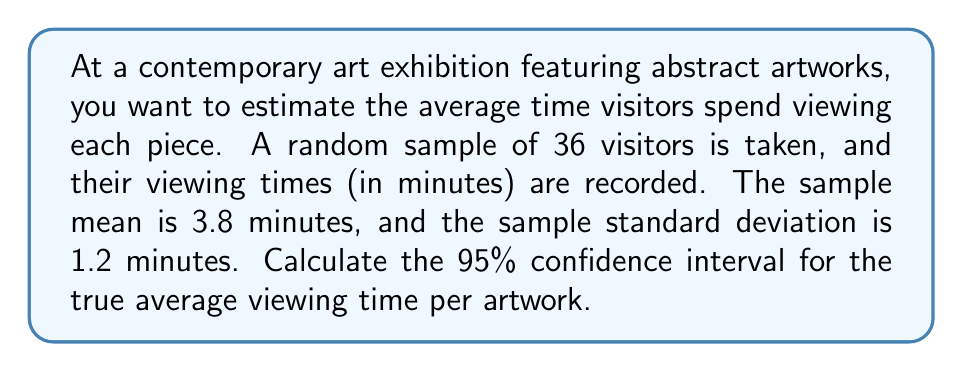Give your solution to this math problem. Let's approach this step-by-step:

1) We're dealing with a confidence interval for a population mean with unknown population standard deviation. We'll use the t-distribution.

2) Given information:
   - Sample size: $n = 36$
   - Sample mean: $\bar{x} = 3.8$ minutes
   - Sample standard deviation: $s = 1.2$ minutes
   - Confidence level: 95%

3) The formula for the confidence interval is:

   $$\bar{x} \pm t_{\alpha/2, n-1} \cdot \frac{s}{\sqrt{n}}$$

4) We need to find $t_{\alpha/2, n-1}$:
   - $\alpha = 1 - 0.95 = 0.05$
   - Degrees of freedom: $df = n - 1 = 35$
   - From t-table or calculator: $t_{0.025, 35} \approx 2.030$

5) Calculate the margin of error:

   $$\text{Margin of Error} = t_{\alpha/2, n-1} \cdot \frac{s}{\sqrt{n}} = 2.030 \cdot \frac{1.2}{\sqrt{36}} \approx 0.406$$

6) Calculate the confidence interval:

   Lower bound: $3.8 - 0.406 = 3.394$
   Upper bound: $3.8 + 0.406 = 4.206$

Therefore, the 95% confidence interval is (3.394, 4.206) minutes.
Answer: (3.394, 4.206) minutes 